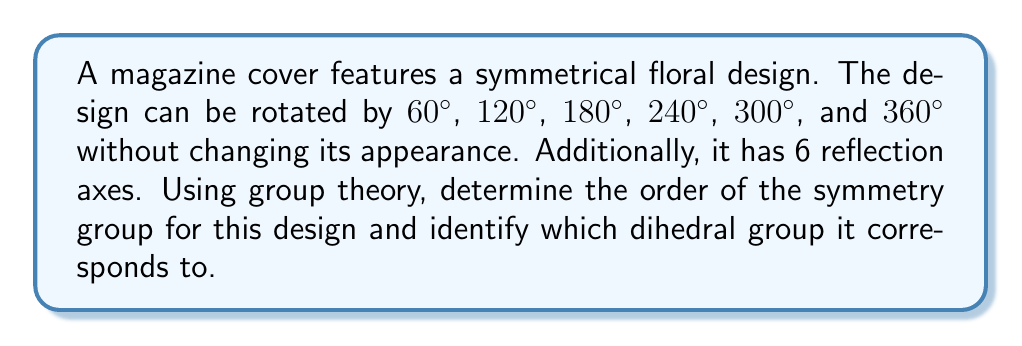Give your solution to this math problem. To solve this problem, we'll follow these steps:

1) First, let's identify the symmetries:
   - 6 rotational symmetries (including the identity rotation of 360°)
   - 6 reflection symmetries

2) The total number of symmetries is the order of the group:
   $6 + 6 = 12$

3) In group theory, a dihedral group $D_n$ is the group of symmetries of a regular n-gon. It has order $2n$, where $n$ is the number of rotational symmetries.

4) Given that we have 6 rotational symmetries, we can determine $n$:
   $2n = 12$
   $n = 6$

5) Therefore, this symmetry group corresponds to $D_6$, the dihedral group of order 12.

6) To visualize this, we can imagine the design as a regular hexagon:

[asy]
unitsize(2cm);
for(int i=0; i<6; ++i) {
  draw(rotate(60*i)*(1,0)--(cos(pi/3),sin(pi/3)), blue);
}
for(int i=0; i<6; ++i) {
  draw(rotate(30+60*i)*(0,0)--(1,0), red+dashed);
}
[/asy]

   The blue lines represent the edges of the hexagon (reflection axes), and the red dashed lines represent the rotation axes.

This group structure explains why the design maintains its appearance under these specific transformations, which is crucial for creating visually balanced and appealing magazine covers.
Answer: $D_6$, order 12 